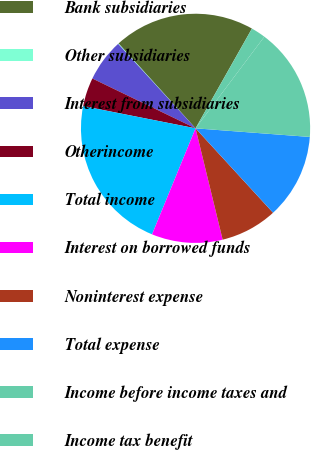<chart> <loc_0><loc_0><loc_500><loc_500><pie_chart><fcel>Bank subsidiaries<fcel>Other subsidiaries<fcel>Interest from subsidiaries<fcel>Otherincome<fcel>Total income<fcel>Interest on borrowed funds<fcel>Noninterest expense<fcel>Total expense<fcel>Income before income taxes and<fcel>Income tax benefit<nl><fcel>19.92%<fcel>0.08%<fcel>6.03%<fcel>4.05%<fcel>21.91%<fcel>10.0%<fcel>8.02%<fcel>11.98%<fcel>15.95%<fcel>2.06%<nl></chart> 